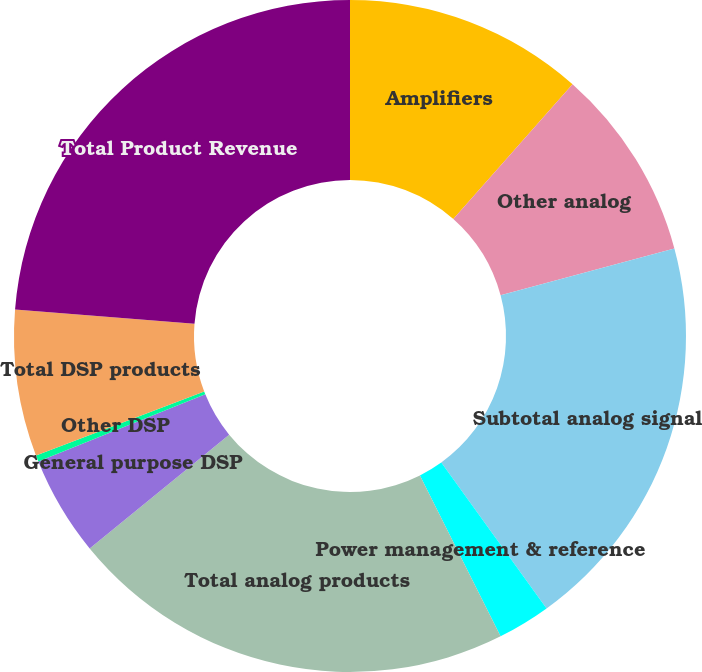<chart> <loc_0><loc_0><loc_500><loc_500><pie_chart><fcel>Amplifiers<fcel>Other analog<fcel>Subtotal analog signal<fcel>Power management & reference<fcel>Total analog products<fcel>General purpose DSP<fcel>Other DSP<fcel>Total DSP products<fcel>Total Product Revenue<nl><fcel>11.52%<fcel>9.28%<fcel>19.25%<fcel>2.55%<fcel>21.5%<fcel>4.8%<fcel>0.31%<fcel>7.04%<fcel>23.74%<nl></chart> 